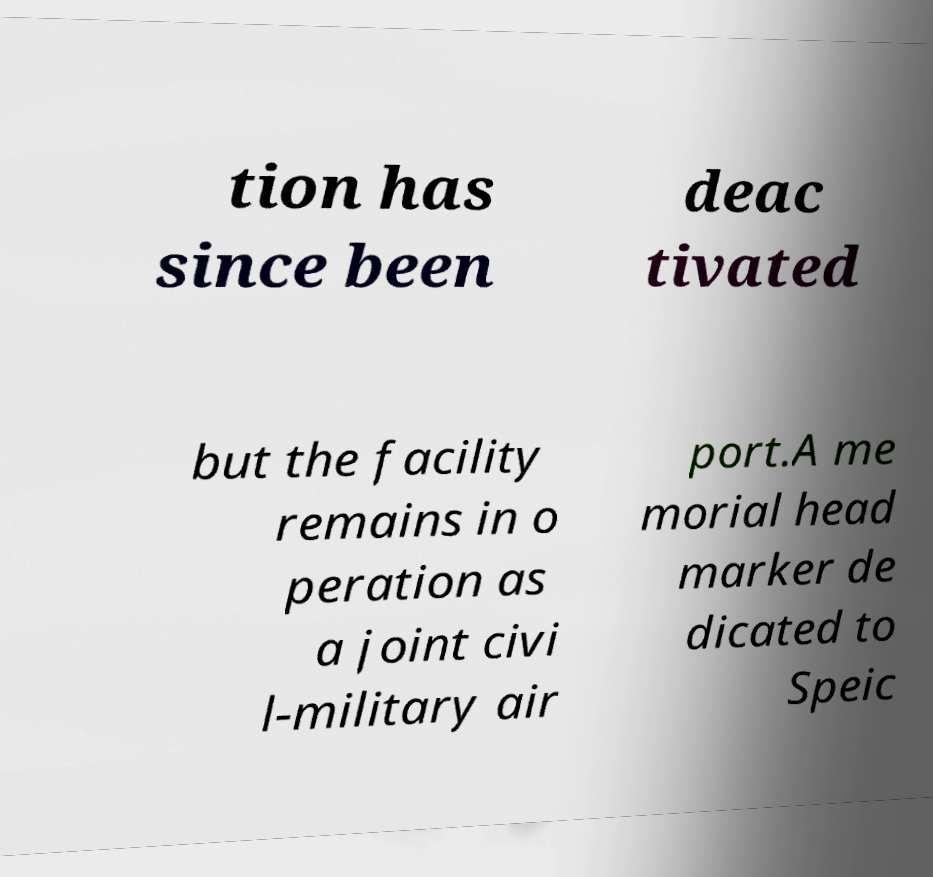Please read and relay the text visible in this image. What does it say? tion has since been deac tivated but the facility remains in o peration as a joint civi l-military air port.A me morial head marker de dicated to Speic 